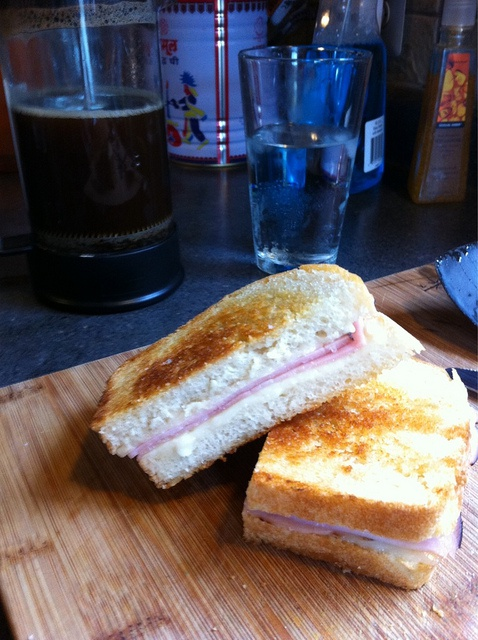Describe the objects in this image and their specific colors. I can see dining table in black, white, gray, darkgray, and maroon tones, cup in black, navy, darkblue, and gray tones, sandwich in black, lightgray, darkgray, brown, and tan tones, sandwich in black, ivory, brown, khaki, and orange tones, and cup in black, navy, blue, and darkblue tones in this image. 